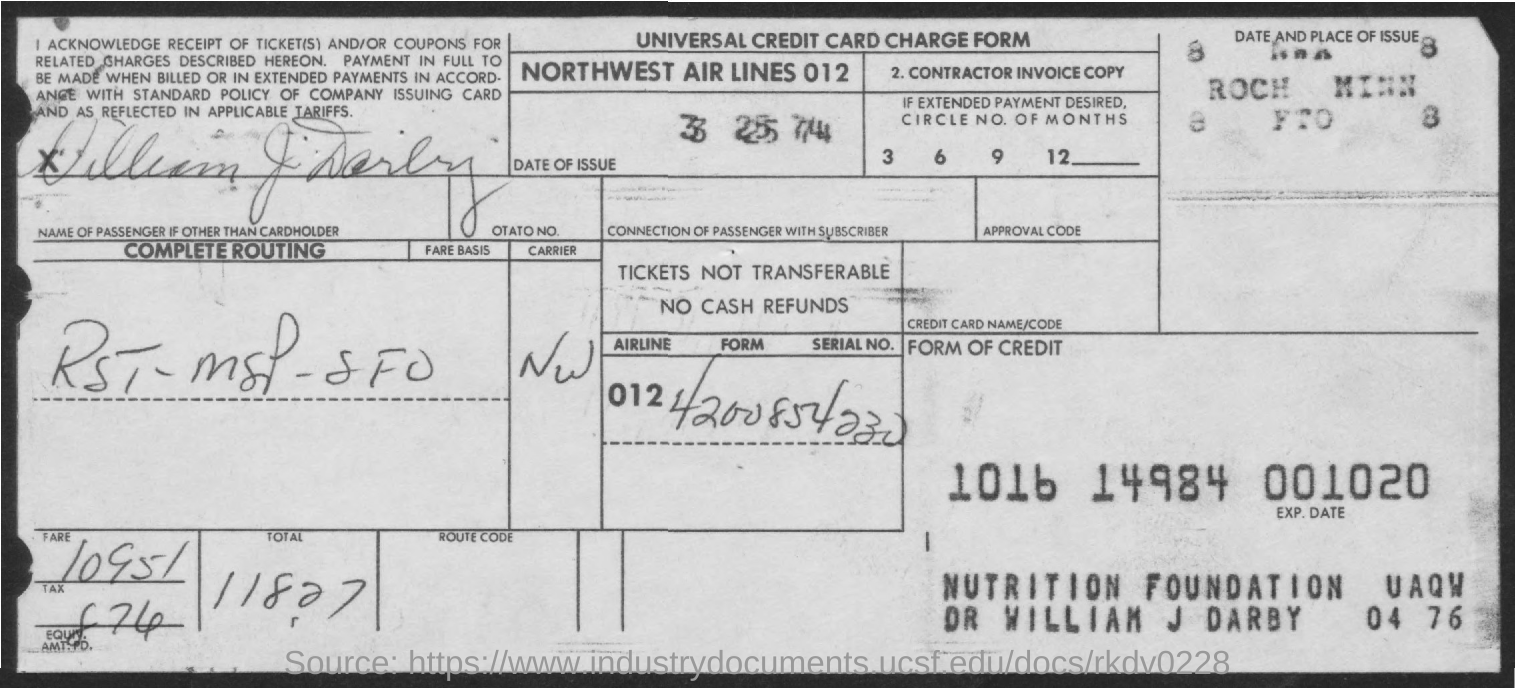What kind of form is given here?
Provide a short and direct response. UNIVERSAL CREDIT CARD CHARGE FORM. What is the date of issue given in the form?
Your answer should be compact. 3 25 74. 